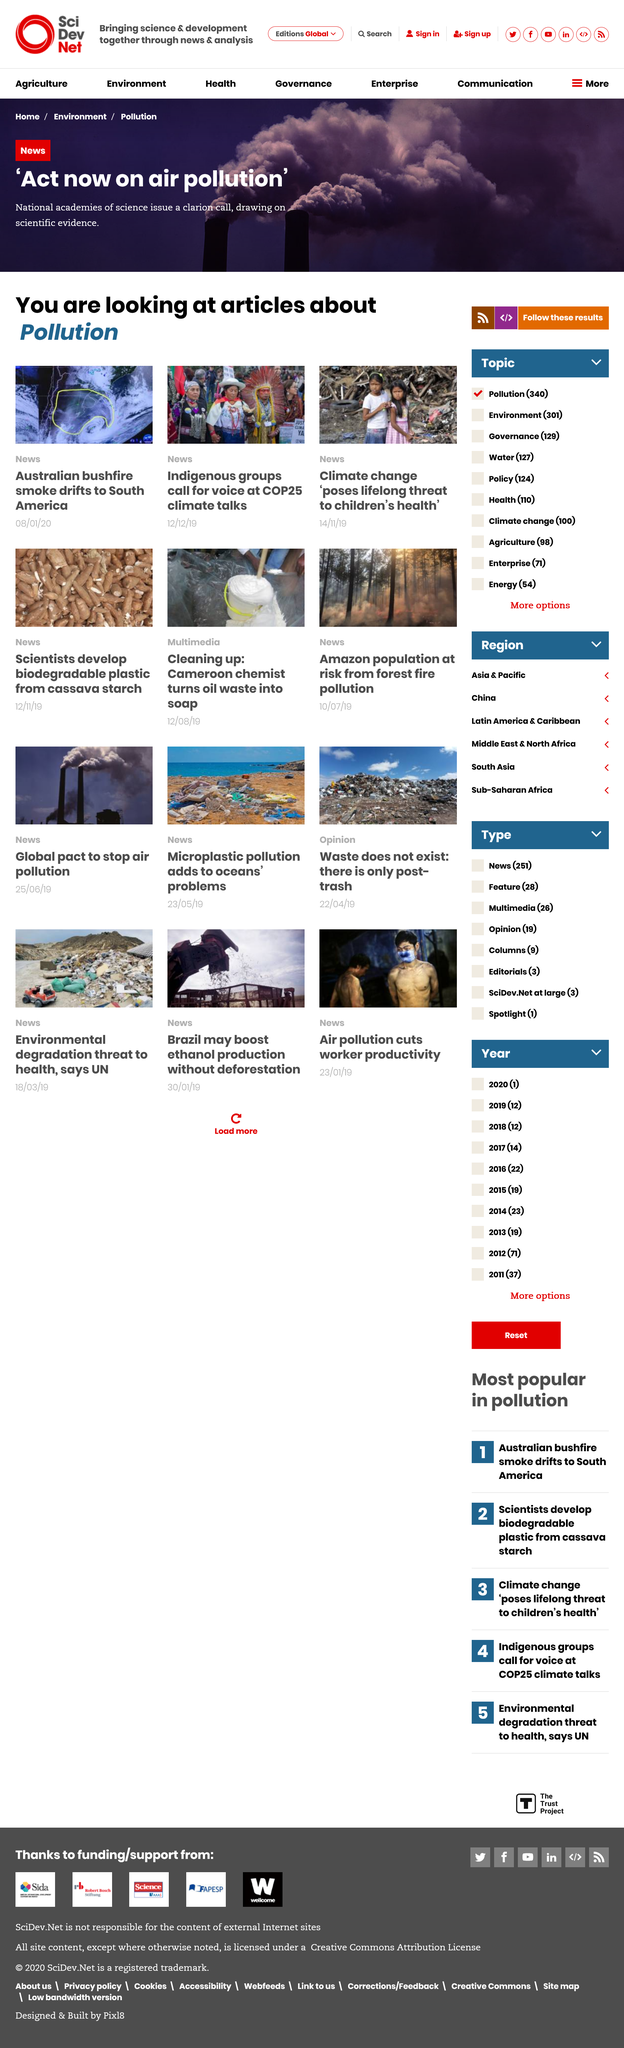Outline some significant characteristics in this image. The articles concern pollution. There are two children depicted in the picture that is related to the article on children's health. The National Academies of Science are issuing a clarion call for action on air pollution. 